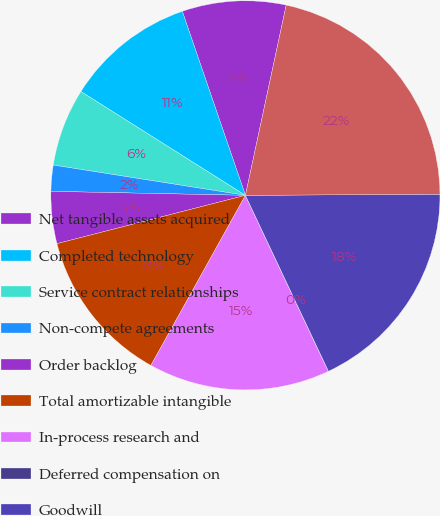<chart> <loc_0><loc_0><loc_500><loc_500><pie_chart><fcel>Net tangible assets acquired<fcel>Completed technology<fcel>Service contract relationships<fcel>Non-compete agreements<fcel>Order backlog<fcel>Total amortizable intangible<fcel>In-process research and<fcel>Deferred compensation on<fcel>Goodwill<fcel>Total purchase price<nl><fcel>8.62%<fcel>10.78%<fcel>6.47%<fcel>2.16%<fcel>4.32%<fcel>12.93%<fcel>15.08%<fcel>0.01%<fcel>18.07%<fcel>21.54%<nl></chart> 